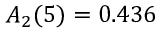Convert formula to latex. <formula><loc_0><loc_0><loc_500><loc_500>A _ { 2 } ( 5 ) = 0 . 4 3 6</formula> 